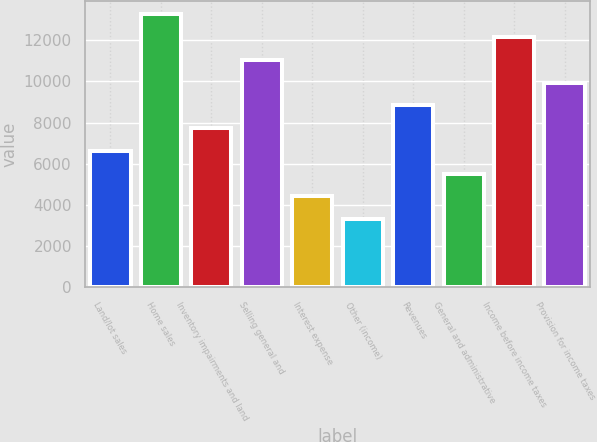<chart> <loc_0><loc_0><loc_500><loc_500><bar_chart><fcel>Land/lot sales<fcel>Home sales<fcel>Inventory impairments and land<fcel>Selling general and<fcel>Interest expense<fcel>Other (income)<fcel>Revenues<fcel>General and administrative<fcel>Income before income taxes<fcel>Provision for income taxes<nl><fcel>6628.88<fcel>13257.3<fcel>7733.62<fcel>11047.8<fcel>4419.4<fcel>3314.66<fcel>8838.36<fcel>5524.14<fcel>12152.6<fcel>9943.1<nl></chart> 